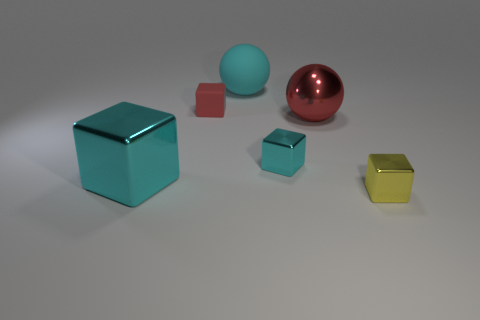How many cyan cubes must be subtracted to get 1 cyan cubes? 1 Subtract all purple balls. How many cyan blocks are left? 2 Subtract 1 cubes. How many cubes are left? 3 Subtract all small cubes. How many cubes are left? 1 Add 2 small metallic cubes. How many objects exist? 8 Subtract all spheres. How many objects are left? 4 Add 4 tiny red rubber blocks. How many tiny red rubber blocks exist? 5 Subtract 0 green blocks. How many objects are left? 6 Subtract all yellow blocks. Subtract all large balls. How many objects are left? 3 Add 3 cyan objects. How many cyan objects are left? 6 